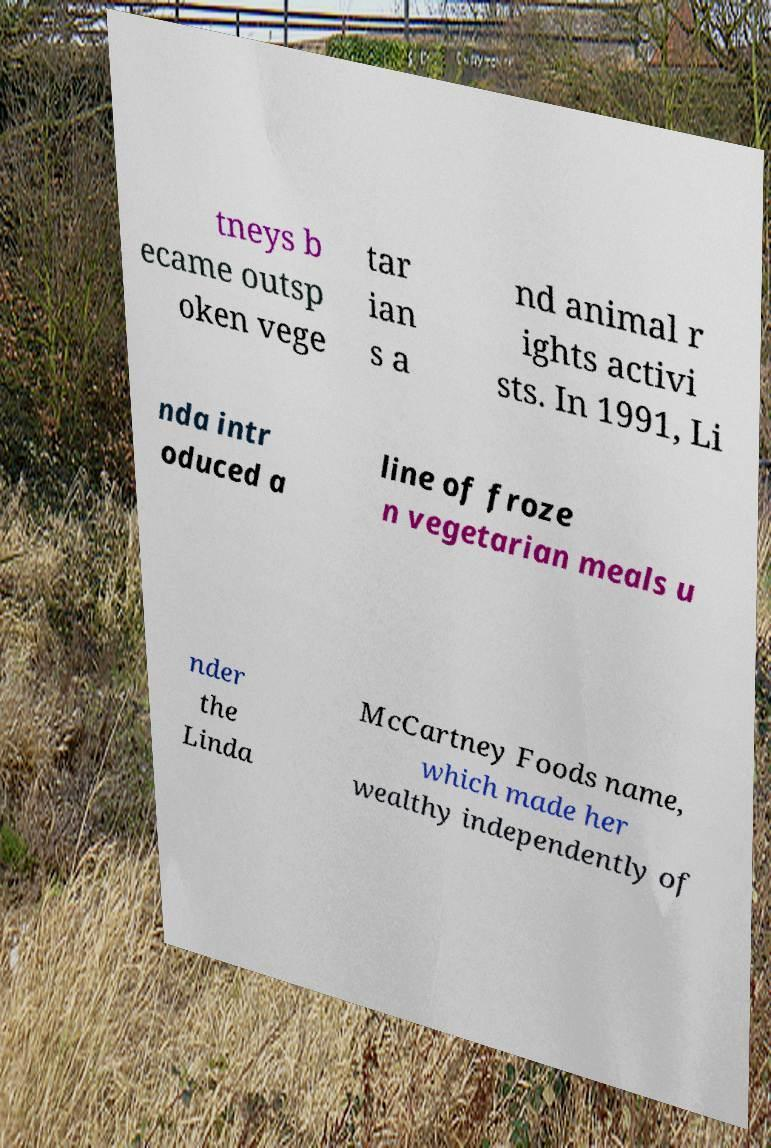Could you extract and type out the text from this image? tneys b ecame outsp oken vege tar ian s a nd animal r ights activi sts. In 1991, Li nda intr oduced a line of froze n vegetarian meals u nder the Linda McCartney Foods name, which made her wealthy independently of 